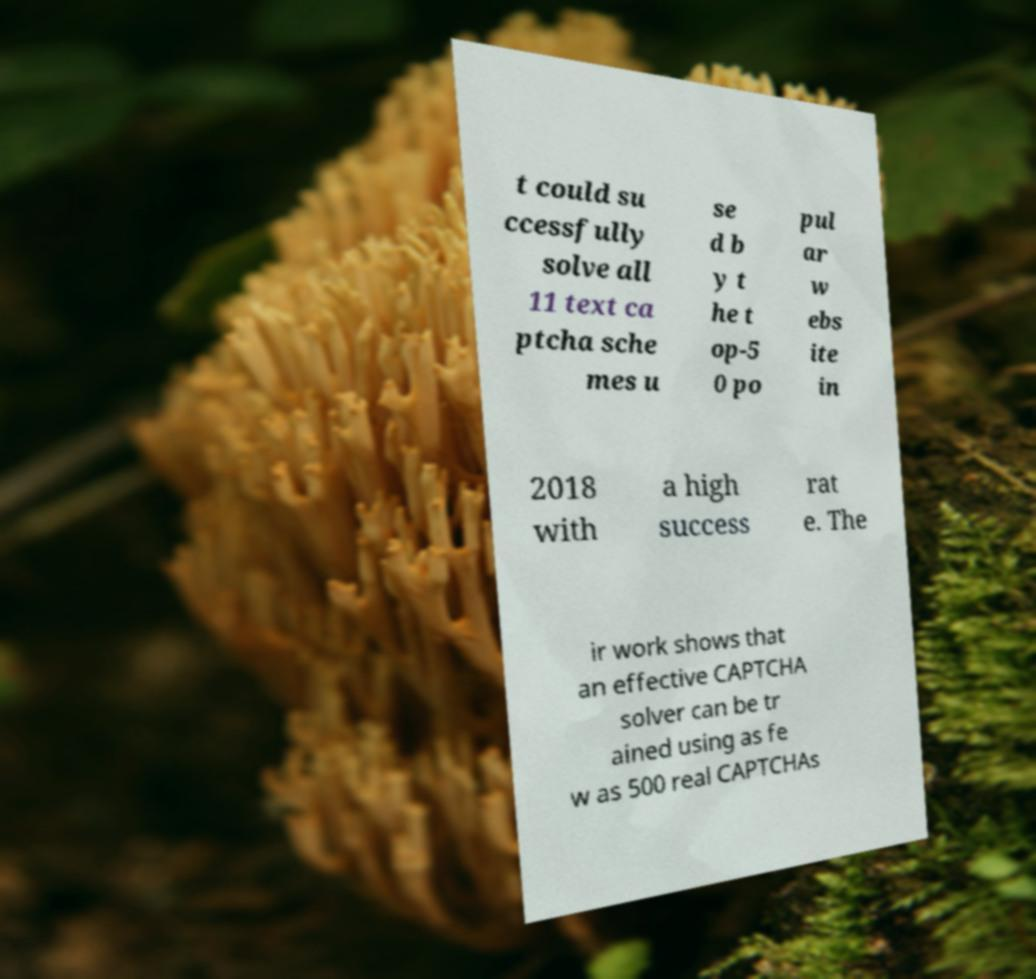Please identify and transcribe the text found in this image. t could su ccessfully solve all 11 text ca ptcha sche mes u se d b y t he t op-5 0 po pul ar w ebs ite in 2018 with a high success rat e. The ir work shows that an effective CAPTCHA solver can be tr ained using as fe w as 500 real CAPTCHAs 